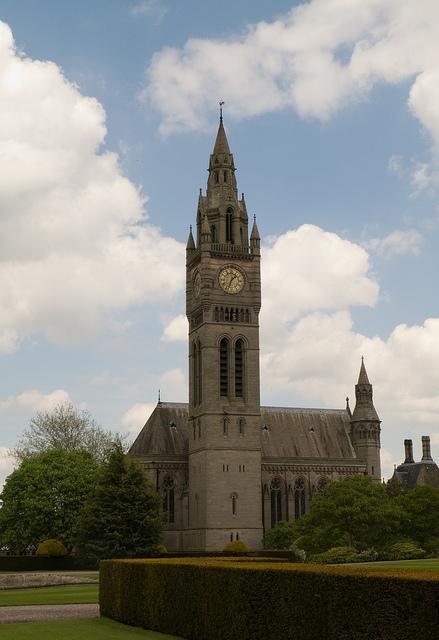How many baby sheep are there?
Give a very brief answer. 0. 